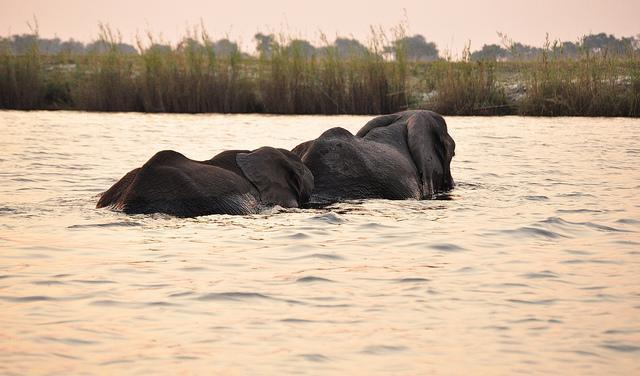How many elephants are there?
Give a very brief answer. 2. 